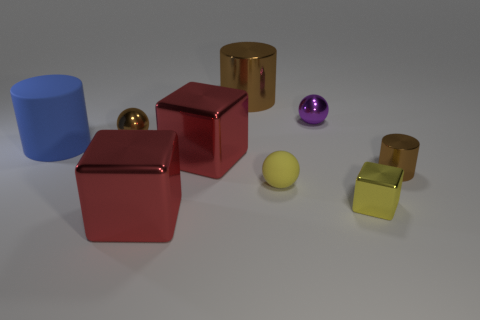Subtract all blocks. How many objects are left? 6 Subtract all small yellow shiny objects. Subtract all red things. How many objects are left? 6 Add 9 small yellow rubber balls. How many small yellow rubber balls are left? 10 Add 9 tiny cylinders. How many tiny cylinders exist? 10 Subtract 0 purple cylinders. How many objects are left? 9 